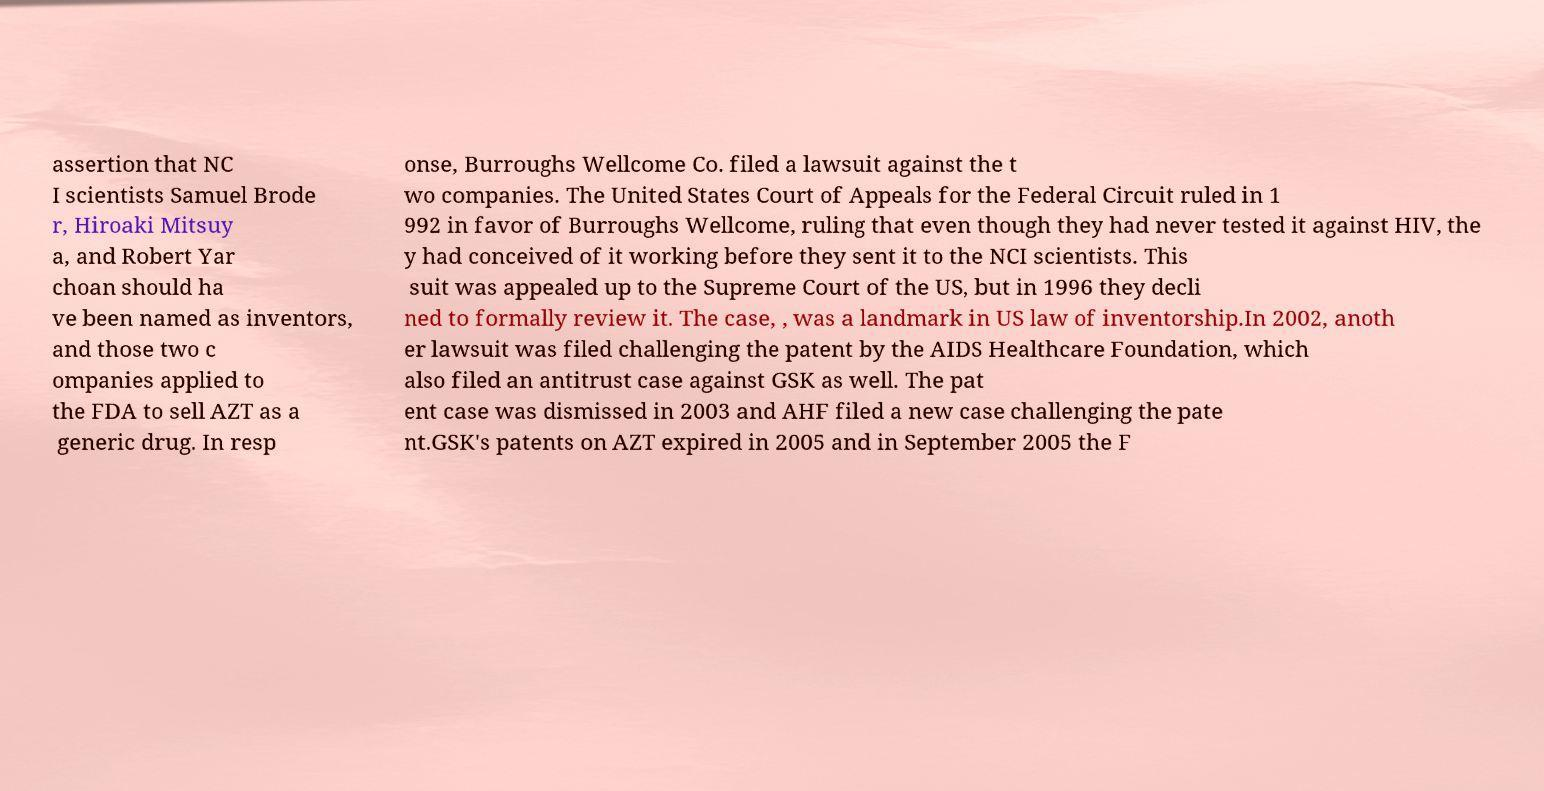Could you assist in decoding the text presented in this image and type it out clearly? assertion that NC I scientists Samuel Brode r, Hiroaki Mitsuy a, and Robert Yar choan should ha ve been named as inventors, and those two c ompanies applied to the FDA to sell AZT as a generic drug. In resp onse, Burroughs Wellcome Co. filed a lawsuit against the t wo companies. The United States Court of Appeals for the Federal Circuit ruled in 1 992 in favor of Burroughs Wellcome, ruling that even though they had never tested it against HIV, the y had conceived of it working before they sent it to the NCI scientists. This suit was appealed up to the Supreme Court of the US, but in 1996 they decli ned to formally review it. The case, , was a landmark in US law of inventorship.In 2002, anoth er lawsuit was filed challenging the patent by the AIDS Healthcare Foundation, which also filed an antitrust case against GSK as well. The pat ent case was dismissed in 2003 and AHF filed a new case challenging the pate nt.GSK's patents on AZT expired in 2005 and in September 2005 the F 